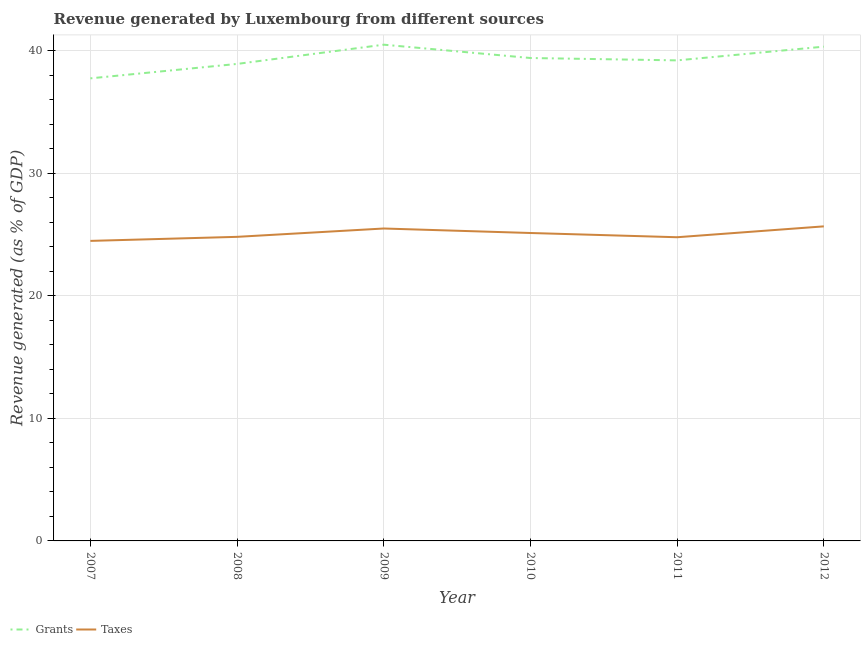Is the number of lines equal to the number of legend labels?
Keep it short and to the point. Yes. What is the revenue generated by taxes in 2009?
Keep it short and to the point. 25.5. Across all years, what is the maximum revenue generated by grants?
Offer a very short reply. 40.5. Across all years, what is the minimum revenue generated by taxes?
Ensure brevity in your answer.  24.48. In which year was the revenue generated by taxes minimum?
Your response must be concise. 2007. What is the total revenue generated by grants in the graph?
Offer a terse response. 236.13. What is the difference between the revenue generated by taxes in 2009 and that in 2012?
Ensure brevity in your answer.  -0.17. What is the difference between the revenue generated by grants in 2011 and the revenue generated by taxes in 2008?
Your response must be concise. 14.4. What is the average revenue generated by grants per year?
Your response must be concise. 39.35. In the year 2010, what is the difference between the revenue generated by grants and revenue generated by taxes?
Give a very brief answer. 14.28. What is the ratio of the revenue generated by grants in 2011 to that in 2012?
Keep it short and to the point. 0.97. Is the revenue generated by taxes in 2008 less than that in 2012?
Keep it short and to the point. Yes. Is the difference between the revenue generated by grants in 2008 and 2012 greater than the difference between the revenue generated by taxes in 2008 and 2012?
Provide a short and direct response. No. What is the difference between the highest and the second highest revenue generated by grants?
Provide a short and direct response. 0.16. What is the difference between the highest and the lowest revenue generated by taxes?
Your answer should be compact. 1.19. In how many years, is the revenue generated by taxes greater than the average revenue generated by taxes taken over all years?
Your answer should be very brief. 3. Does the revenue generated by grants monotonically increase over the years?
Make the answer very short. No. Is the revenue generated by grants strictly greater than the revenue generated by taxes over the years?
Keep it short and to the point. Yes. How many lines are there?
Keep it short and to the point. 2. Are the values on the major ticks of Y-axis written in scientific E-notation?
Make the answer very short. No. Where does the legend appear in the graph?
Your answer should be compact. Bottom left. How many legend labels are there?
Provide a succinct answer. 2. How are the legend labels stacked?
Provide a short and direct response. Horizontal. What is the title of the graph?
Give a very brief answer. Revenue generated by Luxembourg from different sources. What is the label or title of the Y-axis?
Provide a succinct answer. Revenue generated (as % of GDP). What is the Revenue generated (as % of GDP) in Grants in 2007?
Keep it short and to the point. 37.75. What is the Revenue generated (as % of GDP) of Taxes in 2007?
Provide a short and direct response. 24.48. What is the Revenue generated (as % of GDP) in Grants in 2008?
Your answer should be compact. 38.93. What is the Revenue generated (as % of GDP) in Taxes in 2008?
Provide a succinct answer. 24.81. What is the Revenue generated (as % of GDP) of Grants in 2009?
Offer a very short reply. 40.5. What is the Revenue generated (as % of GDP) of Taxes in 2009?
Offer a very short reply. 25.5. What is the Revenue generated (as % of GDP) in Grants in 2010?
Give a very brief answer. 39.41. What is the Revenue generated (as % of GDP) in Taxes in 2010?
Your answer should be compact. 25.13. What is the Revenue generated (as % of GDP) of Grants in 2011?
Ensure brevity in your answer.  39.22. What is the Revenue generated (as % of GDP) in Taxes in 2011?
Provide a succinct answer. 24.78. What is the Revenue generated (as % of GDP) in Grants in 2012?
Your answer should be very brief. 40.34. What is the Revenue generated (as % of GDP) of Taxes in 2012?
Your answer should be compact. 25.67. Across all years, what is the maximum Revenue generated (as % of GDP) in Grants?
Give a very brief answer. 40.5. Across all years, what is the maximum Revenue generated (as % of GDP) of Taxes?
Offer a terse response. 25.67. Across all years, what is the minimum Revenue generated (as % of GDP) in Grants?
Make the answer very short. 37.75. Across all years, what is the minimum Revenue generated (as % of GDP) of Taxes?
Ensure brevity in your answer.  24.48. What is the total Revenue generated (as % of GDP) of Grants in the graph?
Offer a very short reply. 236.13. What is the total Revenue generated (as % of GDP) in Taxes in the graph?
Offer a terse response. 150.37. What is the difference between the Revenue generated (as % of GDP) of Grants in 2007 and that in 2008?
Offer a terse response. -1.18. What is the difference between the Revenue generated (as % of GDP) in Taxes in 2007 and that in 2008?
Offer a terse response. -0.33. What is the difference between the Revenue generated (as % of GDP) of Grants in 2007 and that in 2009?
Your answer should be very brief. -2.75. What is the difference between the Revenue generated (as % of GDP) of Taxes in 2007 and that in 2009?
Ensure brevity in your answer.  -1.01. What is the difference between the Revenue generated (as % of GDP) of Grants in 2007 and that in 2010?
Make the answer very short. -1.66. What is the difference between the Revenue generated (as % of GDP) of Taxes in 2007 and that in 2010?
Offer a very short reply. -0.64. What is the difference between the Revenue generated (as % of GDP) in Grants in 2007 and that in 2011?
Ensure brevity in your answer.  -1.47. What is the difference between the Revenue generated (as % of GDP) of Taxes in 2007 and that in 2011?
Keep it short and to the point. -0.3. What is the difference between the Revenue generated (as % of GDP) in Grants in 2007 and that in 2012?
Provide a short and direct response. -2.59. What is the difference between the Revenue generated (as % of GDP) of Taxes in 2007 and that in 2012?
Offer a terse response. -1.19. What is the difference between the Revenue generated (as % of GDP) of Grants in 2008 and that in 2009?
Offer a very short reply. -1.57. What is the difference between the Revenue generated (as % of GDP) of Taxes in 2008 and that in 2009?
Keep it short and to the point. -0.68. What is the difference between the Revenue generated (as % of GDP) in Grants in 2008 and that in 2010?
Offer a very short reply. -0.48. What is the difference between the Revenue generated (as % of GDP) of Taxes in 2008 and that in 2010?
Give a very brief answer. -0.31. What is the difference between the Revenue generated (as % of GDP) of Grants in 2008 and that in 2011?
Keep it short and to the point. -0.29. What is the difference between the Revenue generated (as % of GDP) of Taxes in 2008 and that in 2011?
Your answer should be very brief. 0.03. What is the difference between the Revenue generated (as % of GDP) in Grants in 2008 and that in 2012?
Your answer should be very brief. -1.41. What is the difference between the Revenue generated (as % of GDP) of Taxes in 2008 and that in 2012?
Provide a short and direct response. -0.86. What is the difference between the Revenue generated (as % of GDP) of Grants in 2009 and that in 2010?
Offer a very short reply. 1.09. What is the difference between the Revenue generated (as % of GDP) of Taxes in 2009 and that in 2010?
Offer a terse response. 0.37. What is the difference between the Revenue generated (as % of GDP) of Grants in 2009 and that in 2011?
Provide a short and direct response. 1.28. What is the difference between the Revenue generated (as % of GDP) of Taxes in 2009 and that in 2011?
Provide a short and direct response. 0.71. What is the difference between the Revenue generated (as % of GDP) of Grants in 2009 and that in 2012?
Keep it short and to the point. 0.16. What is the difference between the Revenue generated (as % of GDP) in Taxes in 2009 and that in 2012?
Your response must be concise. -0.17. What is the difference between the Revenue generated (as % of GDP) in Grants in 2010 and that in 2011?
Ensure brevity in your answer.  0.19. What is the difference between the Revenue generated (as % of GDP) in Taxes in 2010 and that in 2011?
Give a very brief answer. 0.34. What is the difference between the Revenue generated (as % of GDP) in Grants in 2010 and that in 2012?
Offer a very short reply. -0.93. What is the difference between the Revenue generated (as % of GDP) in Taxes in 2010 and that in 2012?
Ensure brevity in your answer.  -0.54. What is the difference between the Revenue generated (as % of GDP) in Grants in 2011 and that in 2012?
Give a very brief answer. -1.12. What is the difference between the Revenue generated (as % of GDP) of Taxes in 2011 and that in 2012?
Ensure brevity in your answer.  -0.89. What is the difference between the Revenue generated (as % of GDP) in Grants in 2007 and the Revenue generated (as % of GDP) in Taxes in 2008?
Keep it short and to the point. 12.93. What is the difference between the Revenue generated (as % of GDP) of Grants in 2007 and the Revenue generated (as % of GDP) of Taxes in 2009?
Your answer should be very brief. 12.25. What is the difference between the Revenue generated (as % of GDP) of Grants in 2007 and the Revenue generated (as % of GDP) of Taxes in 2010?
Keep it short and to the point. 12.62. What is the difference between the Revenue generated (as % of GDP) in Grants in 2007 and the Revenue generated (as % of GDP) in Taxes in 2011?
Make the answer very short. 12.97. What is the difference between the Revenue generated (as % of GDP) of Grants in 2007 and the Revenue generated (as % of GDP) of Taxes in 2012?
Your answer should be very brief. 12.08. What is the difference between the Revenue generated (as % of GDP) of Grants in 2008 and the Revenue generated (as % of GDP) of Taxes in 2009?
Keep it short and to the point. 13.43. What is the difference between the Revenue generated (as % of GDP) of Grants in 2008 and the Revenue generated (as % of GDP) of Taxes in 2010?
Ensure brevity in your answer.  13.8. What is the difference between the Revenue generated (as % of GDP) in Grants in 2008 and the Revenue generated (as % of GDP) in Taxes in 2011?
Offer a terse response. 14.14. What is the difference between the Revenue generated (as % of GDP) in Grants in 2008 and the Revenue generated (as % of GDP) in Taxes in 2012?
Offer a very short reply. 13.26. What is the difference between the Revenue generated (as % of GDP) of Grants in 2009 and the Revenue generated (as % of GDP) of Taxes in 2010?
Ensure brevity in your answer.  15.37. What is the difference between the Revenue generated (as % of GDP) of Grants in 2009 and the Revenue generated (as % of GDP) of Taxes in 2011?
Give a very brief answer. 15.71. What is the difference between the Revenue generated (as % of GDP) in Grants in 2009 and the Revenue generated (as % of GDP) in Taxes in 2012?
Offer a terse response. 14.83. What is the difference between the Revenue generated (as % of GDP) in Grants in 2010 and the Revenue generated (as % of GDP) in Taxes in 2011?
Provide a short and direct response. 14.63. What is the difference between the Revenue generated (as % of GDP) of Grants in 2010 and the Revenue generated (as % of GDP) of Taxes in 2012?
Keep it short and to the point. 13.74. What is the difference between the Revenue generated (as % of GDP) of Grants in 2011 and the Revenue generated (as % of GDP) of Taxes in 2012?
Your answer should be very brief. 13.54. What is the average Revenue generated (as % of GDP) in Grants per year?
Your answer should be compact. 39.35. What is the average Revenue generated (as % of GDP) of Taxes per year?
Provide a succinct answer. 25.06. In the year 2007, what is the difference between the Revenue generated (as % of GDP) of Grants and Revenue generated (as % of GDP) of Taxes?
Provide a short and direct response. 13.26. In the year 2008, what is the difference between the Revenue generated (as % of GDP) in Grants and Revenue generated (as % of GDP) in Taxes?
Offer a terse response. 14.11. In the year 2009, what is the difference between the Revenue generated (as % of GDP) in Grants and Revenue generated (as % of GDP) in Taxes?
Your response must be concise. 15. In the year 2010, what is the difference between the Revenue generated (as % of GDP) of Grants and Revenue generated (as % of GDP) of Taxes?
Provide a short and direct response. 14.28. In the year 2011, what is the difference between the Revenue generated (as % of GDP) of Grants and Revenue generated (as % of GDP) of Taxes?
Offer a terse response. 14.43. In the year 2012, what is the difference between the Revenue generated (as % of GDP) of Grants and Revenue generated (as % of GDP) of Taxes?
Make the answer very short. 14.67. What is the ratio of the Revenue generated (as % of GDP) in Grants in 2007 to that in 2008?
Keep it short and to the point. 0.97. What is the ratio of the Revenue generated (as % of GDP) of Taxes in 2007 to that in 2008?
Your answer should be very brief. 0.99. What is the ratio of the Revenue generated (as % of GDP) in Grants in 2007 to that in 2009?
Your answer should be compact. 0.93. What is the ratio of the Revenue generated (as % of GDP) of Taxes in 2007 to that in 2009?
Offer a terse response. 0.96. What is the ratio of the Revenue generated (as % of GDP) in Grants in 2007 to that in 2010?
Offer a terse response. 0.96. What is the ratio of the Revenue generated (as % of GDP) in Taxes in 2007 to that in 2010?
Offer a very short reply. 0.97. What is the ratio of the Revenue generated (as % of GDP) of Grants in 2007 to that in 2011?
Keep it short and to the point. 0.96. What is the ratio of the Revenue generated (as % of GDP) in Taxes in 2007 to that in 2011?
Keep it short and to the point. 0.99. What is the ratio of the Revenue generated (as % of GDP) in Grants in 2007 to that in 2012?
Give a very brief answer. 0.94. What is the ratio of the Revenue generated (as % of GDP) in Taxes in 2007 to that in 2012?
Give a very brief answer. 0.95. What is the ratio of the Revenue generated (as % of GDP) of Grants in 2008 to that in 2009?
Your answer should be very brief. 0.96. What is the ratio of the Revenue generated (as % of GDP) of Taxes in 2008 to that in 2009?
Make the answer very short. 0.97. What is the ratio of the Revenue generated (as % of GDP) of Grants in 2008 to that in 2010?
Make the answer very short. 0.99. What is the ratio of the Revenue generated (as % of GDP) in Taxes in 2008 to that in 2010?
Offer a terse response. 0.99. What is the ratio of the Revenue generated (as % of GDP) in Grants in 2008 to that in 2011?
Offer a very short reply. 0.99. What is the ratio of the Revenue generated (as % of GDP) of Grants in 2008 to that in 2012?
Keep it short and to the point. 0.97. What is the ratio of the Revenue generated (as % of GDP) in Taxes in 2008 to that in 2012?
Provide a short and direct response. 0.97. What is the ratio of the Revenue generated (as % of GDP) of Grants in 2009 to that in 2010?
Ensure brevity in your answer.  1.03. What is the ratio of the Revenue generated (as % of GDP) in Taxes in 2009 to that in 2010?
Offer a very short reply. 1.01. What is the ratio of the Revenue generated (as % of GDP) of Grants in 2009 to that in 2011?
Your response must be concise. 1.03. What is the ratio of the Revenue generated (as % of GDP) of Taxes in 2009 to that in 2011?
Your answer should be compact. 1.03. What is the ratio of the Revenue generated (as % of GDP) in Taxes in 2009 to that in 2012?
Provide a short and direct response. 0.99. What is the ratio of the Revenue generated (as % of GDP) in Grants in 2010 to that in 2011?
Offer a terse response. 1. What is the ratio of the Revenue generated (as % of GDP) in Taxes in 2010 to that in 2011?
Offer a terse response. 1.01. What is the ratio of the Revenue generated (as % of GDP) of Taxes in 2010 to that in 2012?
Ensure brevity in your answer.  0.98. What is the ratio of the Revenue generated (as % of GDP) of Grants in 2011 to that in 2012?
Provide a succinct answer. 0.97. What is the ratio of the Revenue generated (as % of GDP) in Taxes in 2011 to that in 2012?
Your answer should be compact. 0.97. What is the difference between the highest and the second highest Revenue generated (as % of GDP) in Grants?
Ensure brevity in your answer.  0.16. What is the difference between the highest and the second highest Revenue generated (as % of GDP) of Taxes?
Offer a very short reply. 0.17. What is the difference between the highest and the lowest Revenue generated (as % of GDP) of Grants?
Make the answer very short. 2.75. What is the difference between the highest and the lowest Revenue generated (as % of GDP) in Taxes?
Offer a very short reply. 1.19. 